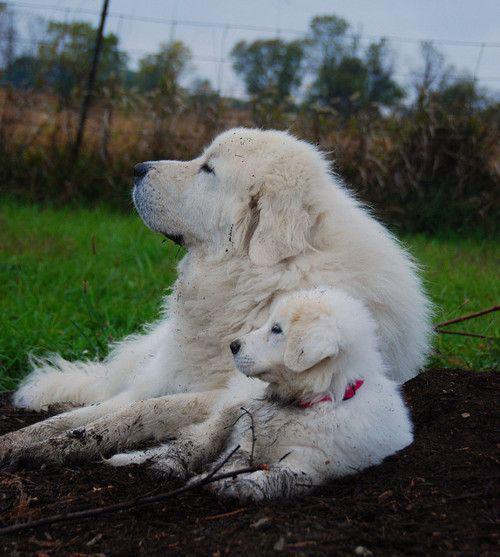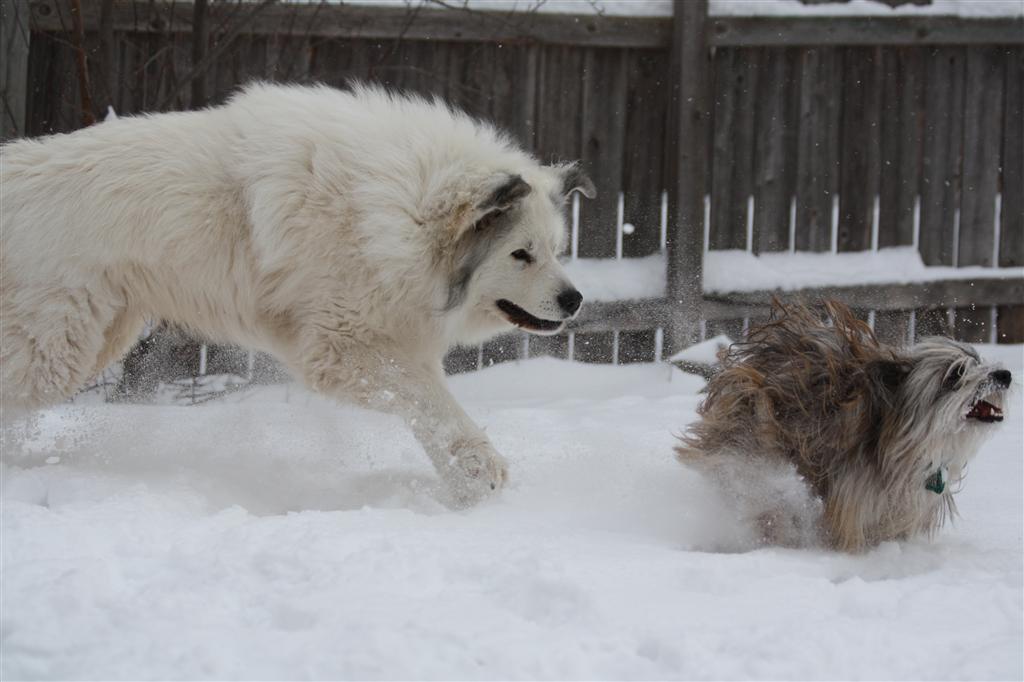The first image is the image on the left, the second image is the image on the right. For the images displayed, is the sentence "There is at least one human with the dogs." factually correct? Answer yes or no. No. The first image is the image on the left, the second image is the image on the right. For the images displayed, is the sentence "There is at least 1 white dog and 1 person outside with a herd of sheep in the back." factually correct? Answer yes or no. No. 